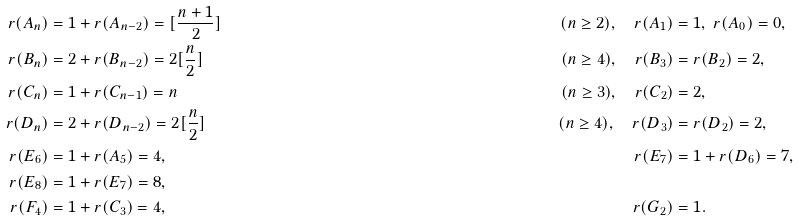<formula> <loc_0><loc_0><loc_500><loc_500>r ( A _ { n } ) & = 1 + r ( A _ { n - 2 } ) = [ \frac { n + 1 } 2 ] & ( n \geq 2 ) , \quad r ( A _ { 1 } ) & = 1 , \ r ( A _ { 0 } ) = 0 , \\ r ( B _ { n } ) & = 2 + r ( B _ { n - 2 } ) = 2 [ \frac { n } { 2 } ] & ( n \geq 4 ) , \quad r ( B _ { 3 } ) & = r ( B _ { 2 } ) = 2 , \\ r ( C _ { n } ) & = 1 + r ( C _ { n - 1 } ) = n & ( n \geq 3 ) , \quad r ( C _ { 2 } ) & = 2 , \\ r ( D _ { n } ) & = 2 + r ( D _ { n - 2 } ) = 2 [ \frac { n } { 2 } ] & ( n \geq 4 ) , \quad r ( D _ { 3 } ) & = r ( D _ { 2 } ) = 2 , \\ r ( E _ { 6 } ) & = 1 + r ( A _ { 5 } ) = 4 , & r ( E _ { 7 } ) & = 1 + r ( D _ { 6 } ) = 7 , \\ r ( E _ { 8 } ) & = 1 + r ( E _ { 7 } ) = 8 , \\ r ( F _ { 4 } ) & = 1 + r ( C _ { 3 } ) = 4 , & r ( G _ { 2 } ) & = 1 .</formula> 